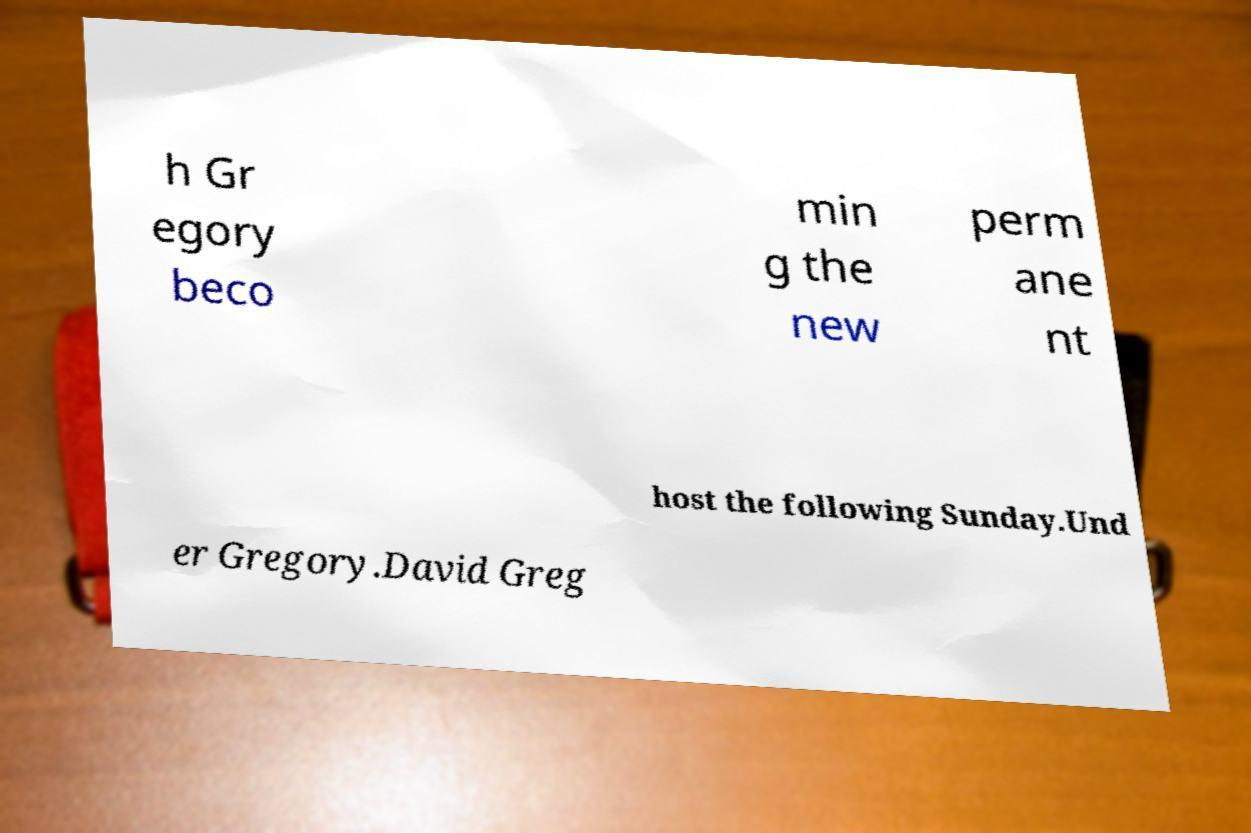For documentation purposes, I need the text within this image transcribed. Could you provide that? h Gr egory beco min g the new perm ane nt host the following Sunday.Und er Gregory.David Greg 